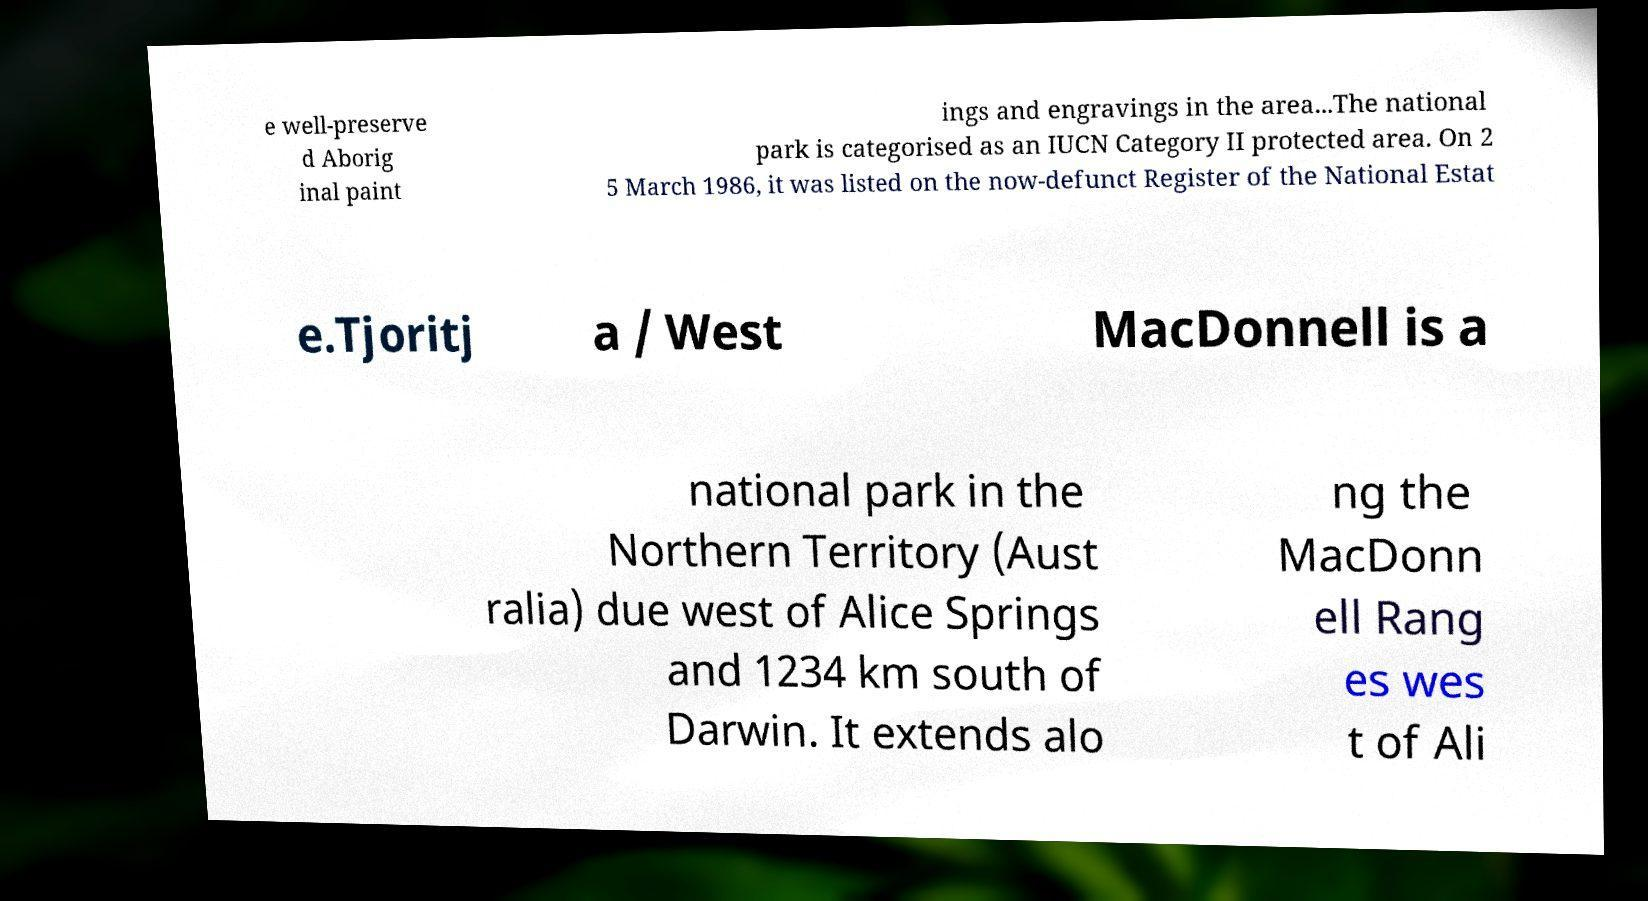For documentation purposes, I need the text within this image transcribed. Could you provide that? e well-preserve d Aborig inal paint ings and engravings in the area...The national park is categorised as an IUCN Category II protected area. On 2 5 March 1986, it was listed on the now-defunct Register of the National Estat e.Tjoritj a / West MacDonnell is a national park in the Northern Territory (Aust ralia) due west of Alice Springs and 1234 km south of Darwin. It extends alo ng the MacDonn ell Rang es wes t of Ali 